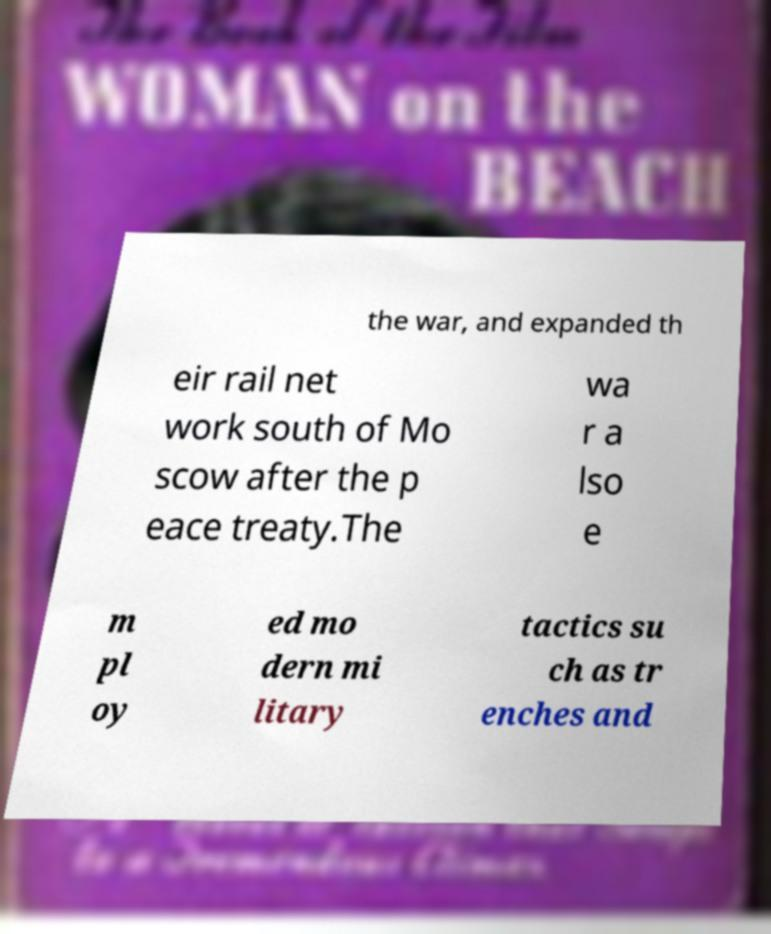Could you assist in decoding the text presented in this image and type it out clearly? the war, and expanded th eir rail net work south of Mo scow after the p eace treaty.The wa r a lso e m pl oy ed mo dern mi litary tactics su ch as tr enches and 